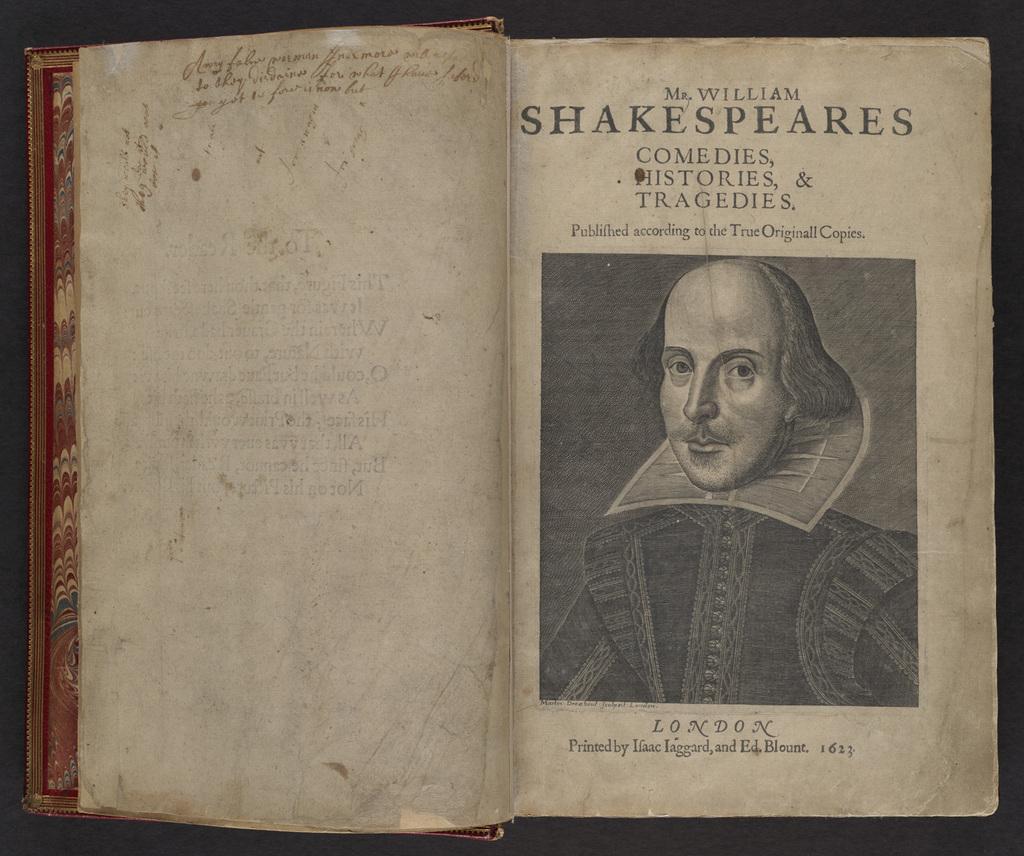Could you give a brief overview of what you see in this image? This picture shows a book and we see a man on it and some text. 